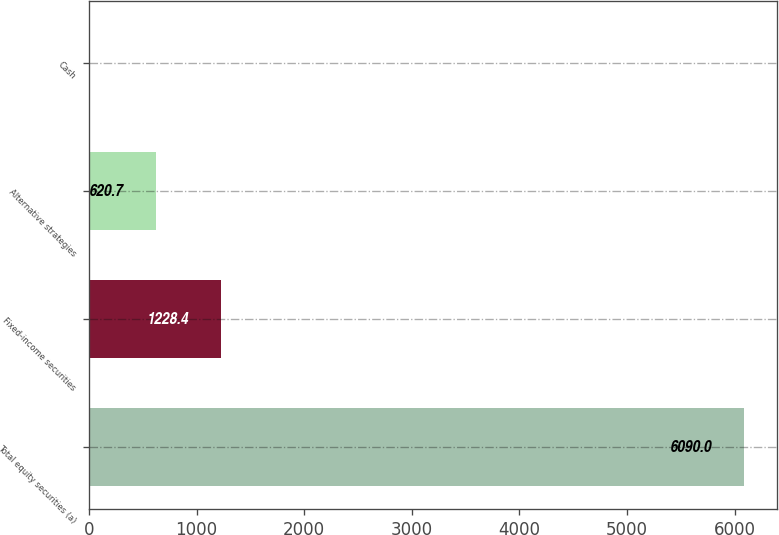<chart> <loc_0><loc_0><loc_500><loc_500><bar_chart><fcel>Total equity securities (a)<fcel>Fixed-income securities<fcel>Alternative strategies<fcel>Cash<nl><fcel>6090<fcel>1228.4<fcel>620.7<fcel>13<nl></chart> 